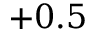<formula> <loc_0><loc_0><loc_500><loc_500>+ 0 . 5</formula> 